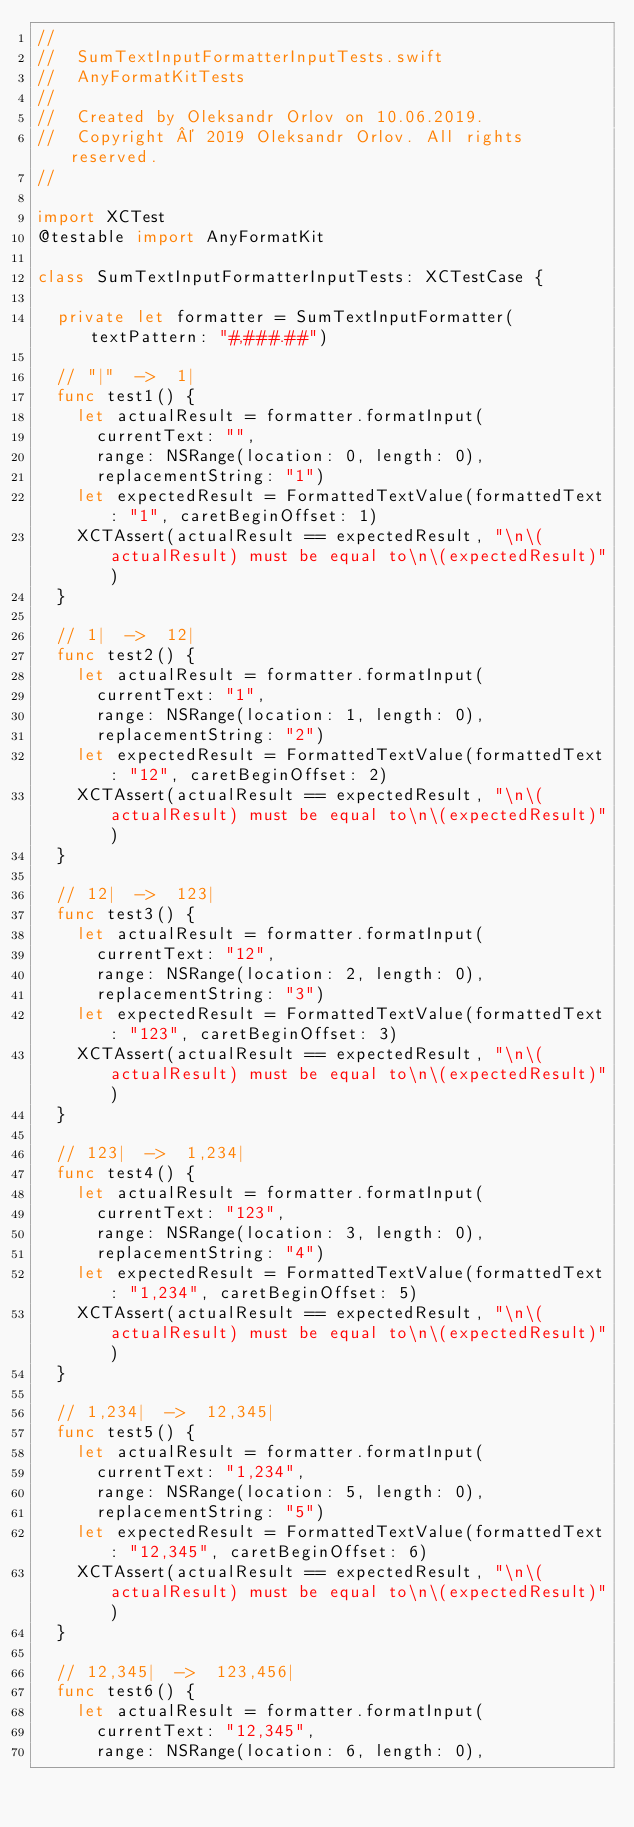<code> <loc_0><loc_0><loc_500><loc_500><_Swift_>//
//  SumTextInputFormatterInputTests.swift
//  AnyFormatKitTests
//
//  Created by Oleksandr Orlov on 10.06.2019.
//  Copyright © 2019 Oleksandr Orlov. All rights reserved.
//

import XCTest
@testable import AnyFormatKit

class SumTextInputFormatterInputTests: XCTestCase {

  private let formatter = SumTextInputFormatter(textPattern: "#,###.##")
  
  // "|"  ->  1|
  func test1() {
    let actualResult = formatter.formatInput(
      currentText: "",
      range: NSRange(location: 0, length: 0),
      replacementString: "1")
    let expectedResult = FormattedTextValue(formattedText: "1", caretBeginOffset: 1)
    XCTAssert(actualResult == expectedResult, "\n\(actualResult) must be equal to\n\(expectedResult)")
  }
  
  // 1|  ->  12|
  func test2() {
    let actualResult = formatter.formatInput(
      currentText: "1",
      range: NSRange(location: 1, length: 0),
      replacementString: "2")
    let expectedResult = FormattedTextValue(formattedText: "12", caretBeginOffset: 2)
    XCTAssert(actualResult == expectedResult, "\n\(actualResult) must be equal to\n\(expectedResult)")
  }
  
  // 12|  ->  123|
  func test3() {
    let actualResult = formatter.formatInput(
      currentText: "12",
      range: NSRange(location: 2, length: 0),
      replacementString: "3")
    let expectedResult = FormattedTextValue(formattedText: "123", caretBeginOffset: 3)
    XCTAssert(actualResult == expectedResult, "\n\(actualResult) must be equal to\n\(expectedResult)")
  }
  
  // 123|  ->  1,234|
  func test4() {
    let actualResult = formatter.formatInput(
      currentText: "123",
      range: NSRange(location: 3, length: 0),
      replacementString: "4")
    let expectedResult = FormattedTextValue(formattedText: "1,234", caretBeginOffset: 5)
    XCTAssert(actualResult == expectedResult, "\n\(actualResult) must be equal to\n\(expectedResult)")
  }
  
  // 1,234|  ->  12,345|
  func test5() {
    let actualResult = formatter.formatInput(
      currentText: "1,234",
      range: NSRange(location: 5, length: 0),
      replacementString: "5")
    let expectedResult = FormattedTextValue(formattedText: "12,345", caretBeginOffset: 6)
    XCTAssert(actualResult == expectedResult, "\n\(actualResult) must be equal to\n\(expectedResult)")
  }
  
  // 12,345|  ->  123,456|
  func test6() {
    let actualResult = formatter.formatInput(
      currentText: "12,345",
      range: NSRange(location: 6, length: 0),</code> 